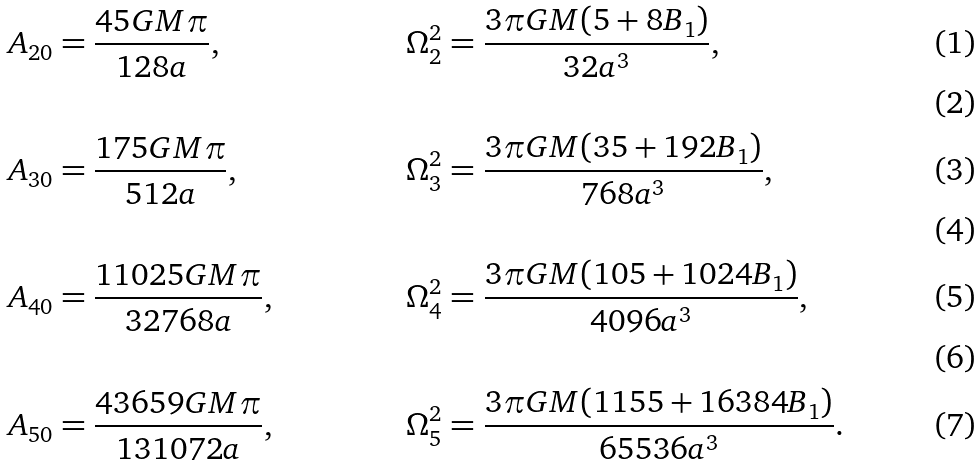<formula> <loc_0><loc_0><loc_500><loc_500>A _ { 2 0 } & = \frac { 4 5 G M \pi } { 1 2 8 a } , & \Omega _ { 2 } ^ { 2 } & = \frac { 3 \pi G M ( 5 + 8 B _ { 1 } ) } { 3 2 a ^ { 3 } } , \\ & & & \\ A _ { 3 0 } & = \frac { 1 7 5 G M \pi } { 5 1 2 a } , & \Omega _ { 3 } ^ { 2 } & = \frac { 3 \pi G M ( 3 5 + 1 9 2 B _ { 1 } ) } { 7 6 8 a ^ { 3 } } , \\ & & & \\ A _ { 4 0 } & = \frac { 1 1 0 2 5 G M \pi } { 3 2 7 6 8 a } , & \Omega _ { 4 } ^ { 2 } & = \frac { 3 \pi G M ( 1 0 5 + 1 0 2 4 B _ { 1 } ) } { 4 0 9 6 a ^ { 3 } } , \\ & & & \\ A _ { 5 0 } & = \frac { 4 3 6 5 9 G M \pi } { 1 3 1 0 7 2 a } , & \Omega _ { 5 } ^ { 2 } & = \frac { 3 \pi G M ( 1 1 5 5 + 1 6 3 8 4 B _ { 1 } ) } { 6 5 5 3 6 a ^ { 3 } } .</formula> 